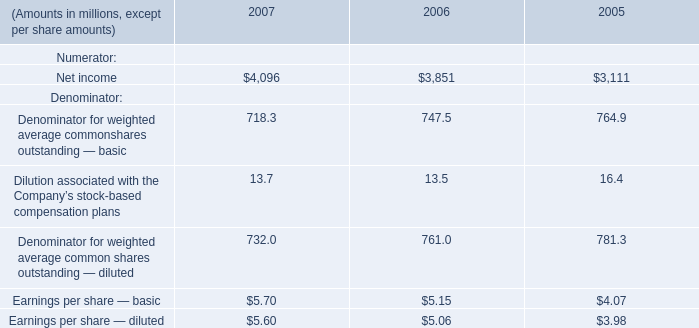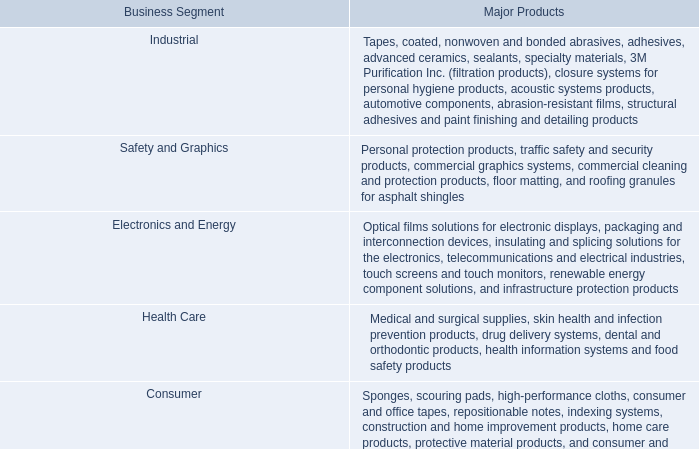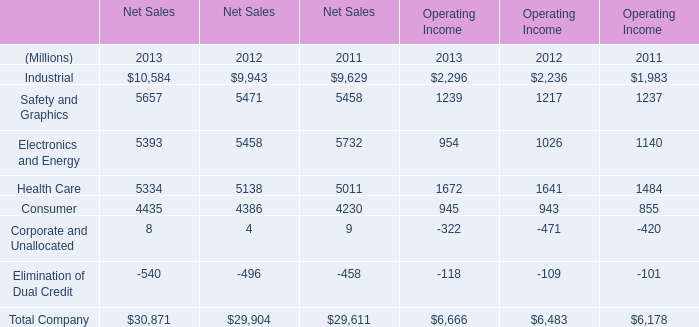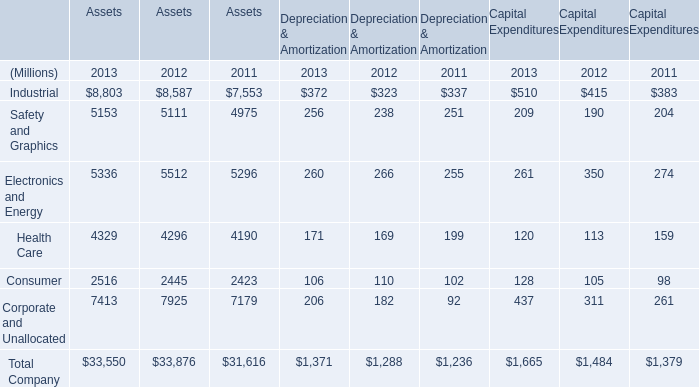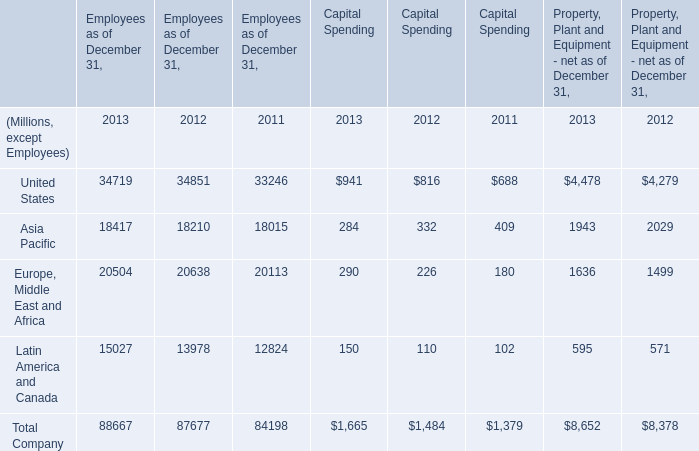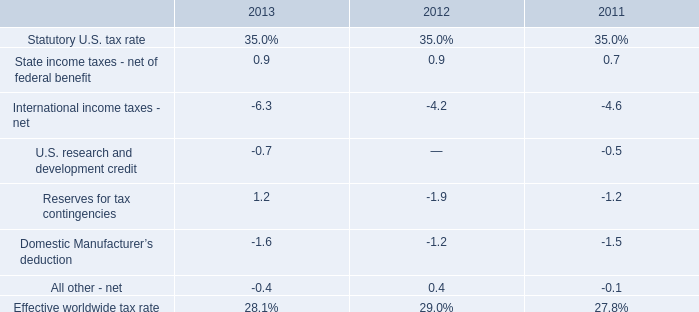what was the percentage change in the domestic manufacturer 2019s deduction activity from 2012 to 2013 
Computations: ((1.6 - 1.2) / 1.2)
Answer: 0.33333. 